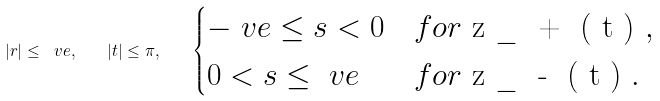Convert formula to latex. <formula><loc_0><loc_0><loc_500><loc_500>| r | \leq \ v e , \quad | t | \leq \pi , \quad \begin{cases} - \ v e \leq s < 0 & f o r $ z _ { + } ( t ) $ , \\ 0 < s \leq \ v e & f o r $ z _ { - } ( t ) $ . \end{cases}</formula> 